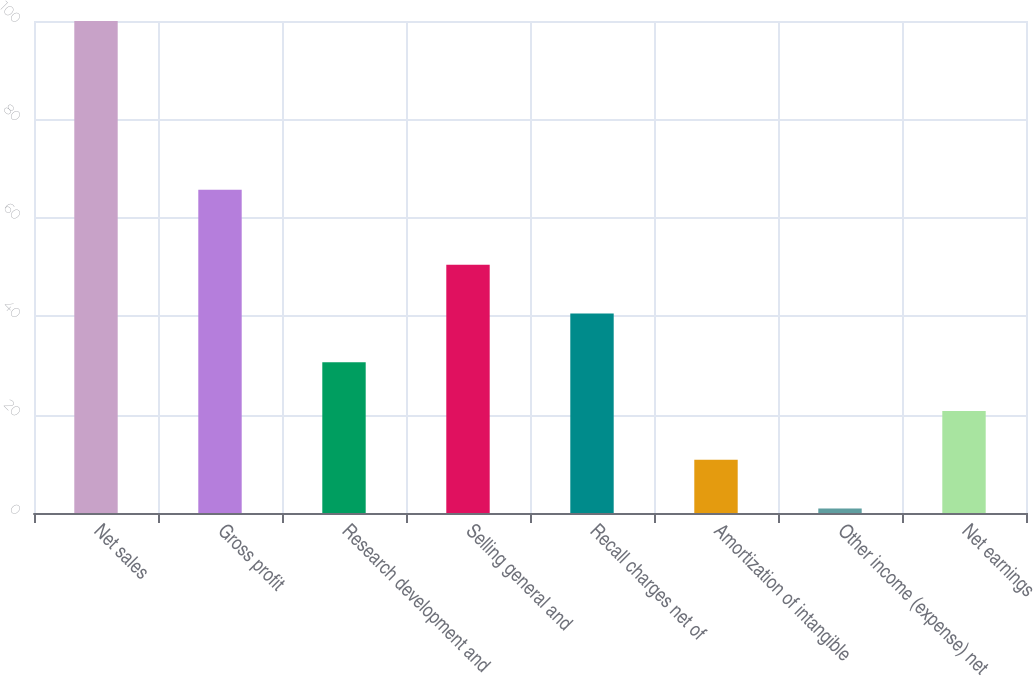<chart> <loc_0><loc_0><loc_500><loc_500><bar_chart><fcel>Net sales<fcel>Gross profit<fcel>Research development and<fcel>Selling general and<fcel>Recall charges net of<fcel>Amortization of intangible<fcel>Other income (expense) net<fcel>Net earnings<nl><fcel>100<fcel>65.7<fcel>30.63<fcel>50.45<fcel>40.54<fcel>10.81<fcel>0.9<fcel>20.72<nl></chart> 